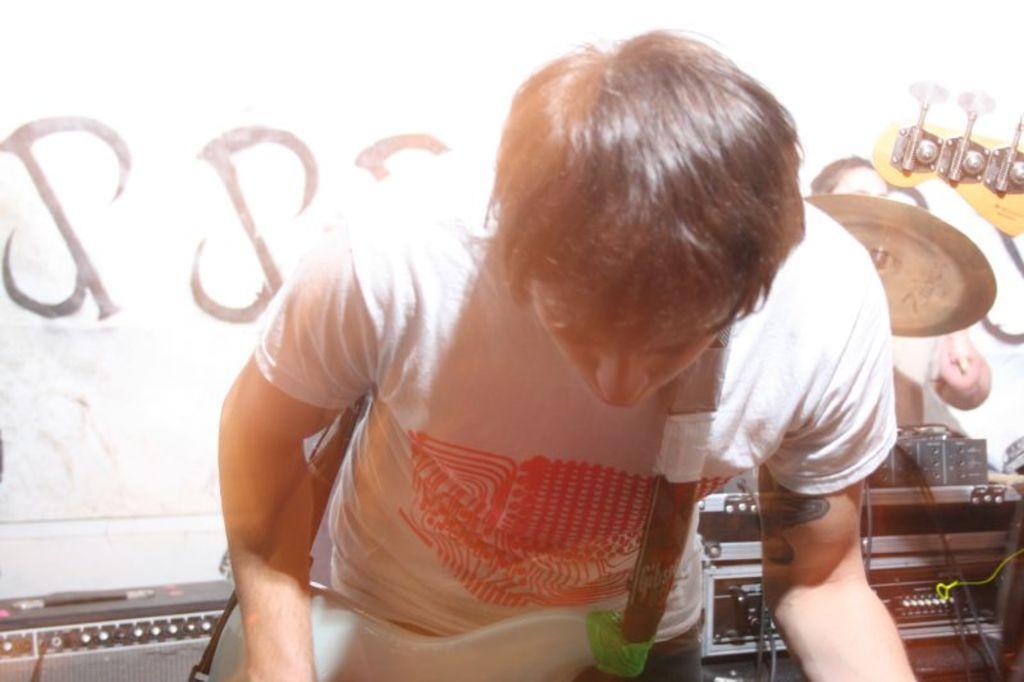Could you give a brief overview of what you see in this image? There is a man wore guitar. Background we can see electrical devices,drum plate and person. 